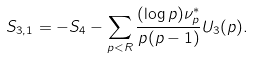<formula> <loc_0><loc_0><loc_500><loc_500>S _ { 3 , 1 } = - S _ { 4 } - \sum _ { p < R } \frac { ( \log p ) \nu ^ { * } _ { p } } { p ( p - 1 ) } U _ { 3 } ( p ) .</formula> 